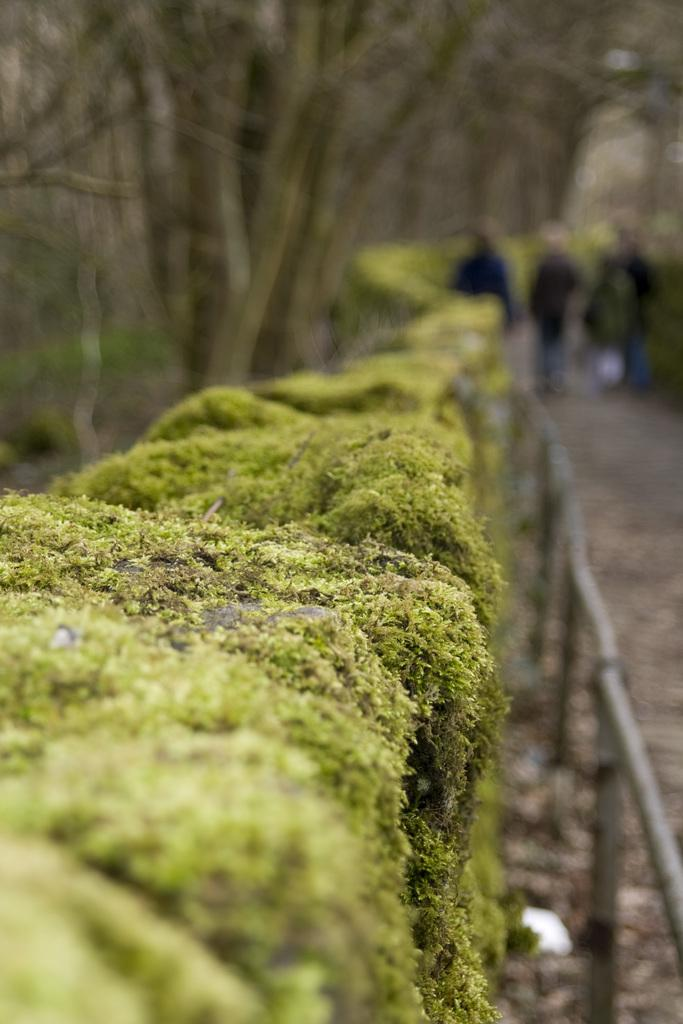What can be seen in the image? There are persons standing in the image. What is present in the image that separates or encloses an area? There is a fence in the image. What type of vegetation is visible in the image? There are plants in the image. What can be seen in the distance in the image? There are trees in the background of the image. What type of science is being conducted in the image? There is no indication of any scientific activity in the image. Is there a hospital visible in the image? No, there is no hospital present in the image. 